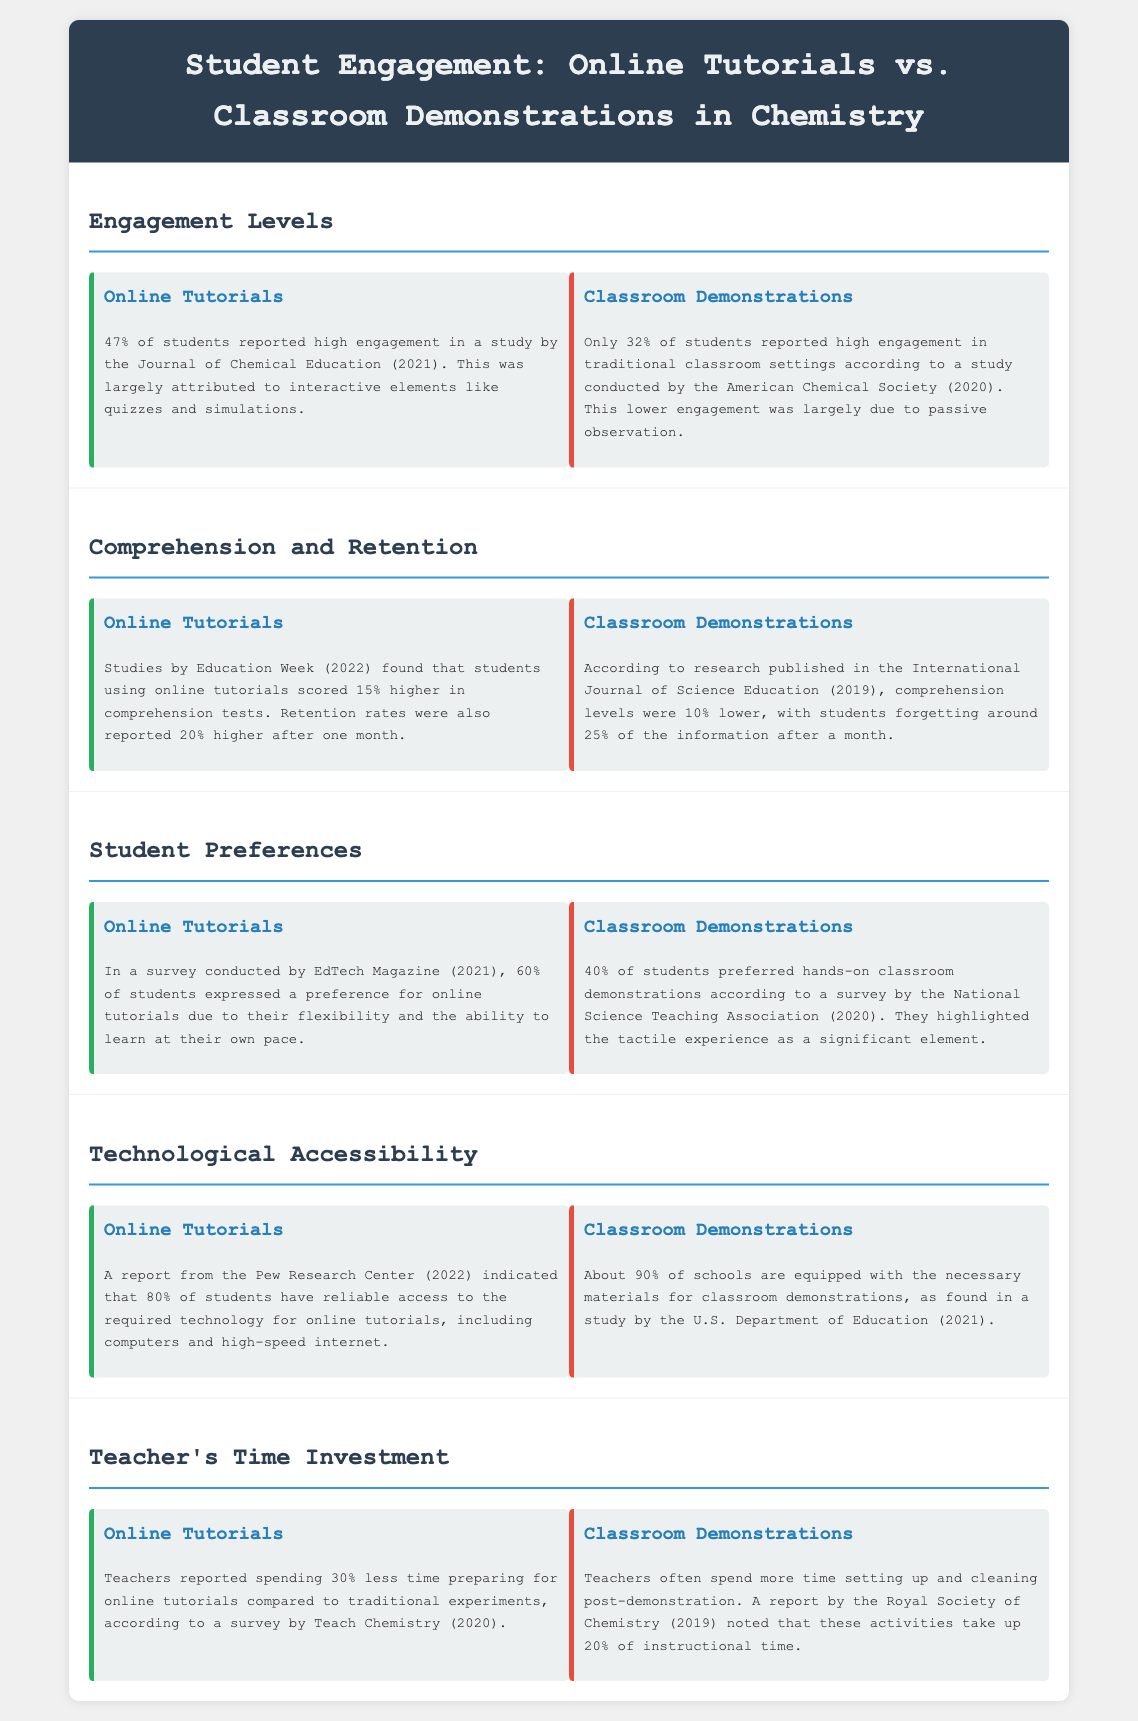what percentage of students reported high engagement in online tutorials? The document states that 47% of students reported high engagement in online tutorials according to the Journal of Chemical Education (2021).
Answer: 47% what percentage of students reported high engagement in classroom demonstrations? According to a study by the American Chemical Society (2020), only 32% of students reported high engagement in traditional classroom settings.
Answer: 32% how much higher did students score in comprehension tests when using online tutorials? The document mentions that students using online tutorials scored 15% higher in comprehension tests, as found by Education Week (2022).
Answer: 15% what was the retention rate difference after one month for students using online tutorials compared to those in classrooms? The retention rates were reported to be 20% higher for students using online tutorials after one month, according to the same source (Education Week, 2022).
Answer: 20% what percentage of students expressed a preference for online tutorials? A survey by EdTech Magazine (2021) indicated that 60% of students expressed a preference for online tutorials.
Answer: 60% what is the technological accessibility percentage for students regarding online tutorials? A report from the Pew Research Center (2022) stated that 80% of students have reliable access to the required technology for online tutorials.
Answer: 80% how much less time do teachers spend preparing for online tutorials compared to classroom demonstrations? The survey by Teach Chemistry (2020) indicated that teachers reported spending 30% less time preparing for online tutorials.
Answer: 30% which type of instruction allows teachers to spend 20% of instructional time on setup and cleaning? The document states that classroom demonstrations require teachers to spend 20% of instructional time on setup and cleaning, according to a report by the Royal Society of Chemistry (2019).
Answer: Classroom Demonstrations 